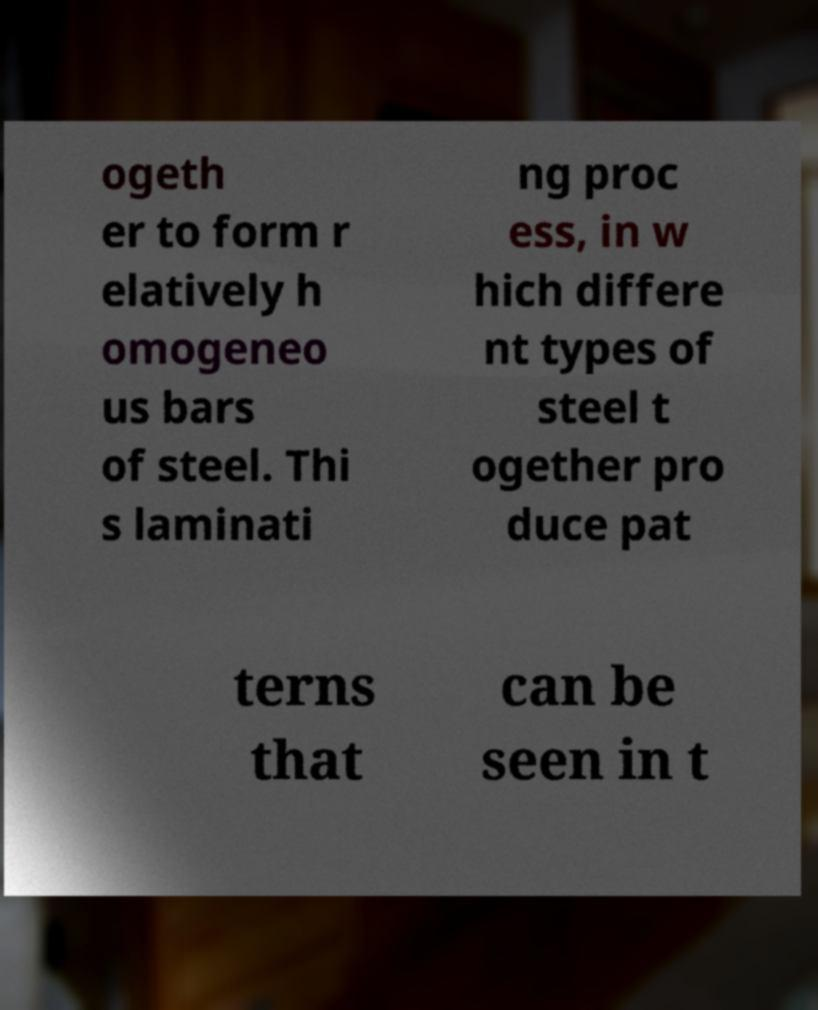For documentation purposes, I need the text within this image transcribed. Could you provide that? ogeth er to form r elatively h omogeneo us bars of steel. Thi s laminati ng proc ess, in w hich differe nt types of steel t ogether pro duce pat terns that can be seen in t 